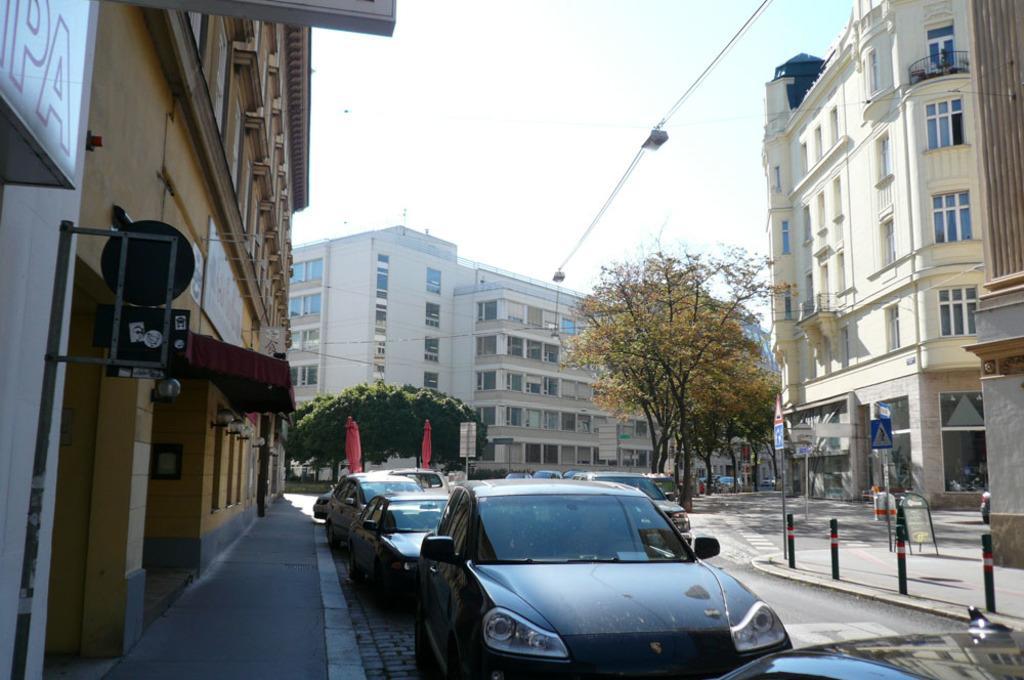Please provide a concise description of this image. In this image I can see at the bottom there are cars on the road. There are buildings on either side of this image. At the back side there are trees, at the top it is the sky. 